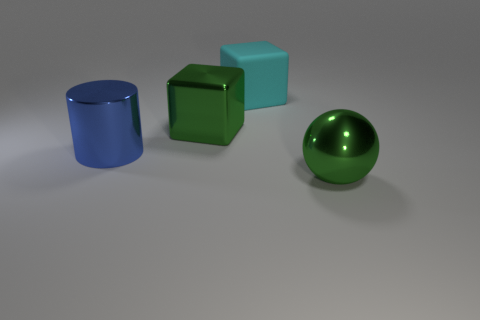Add 1 matte objects. How many objects exist? 5 Subtract all cylinders. How many objects are left? 3 Subtract 0 gray balls. How many objects are left? 4 Subtract all large purple cylinders. Subtract all big green shiny balls. How many objects are left? 3 Add 1 cyan cubes. How many cyan cubes are left? 2 Add 1 blue metal cylinders. How many blue metal cylinders exist? 2 